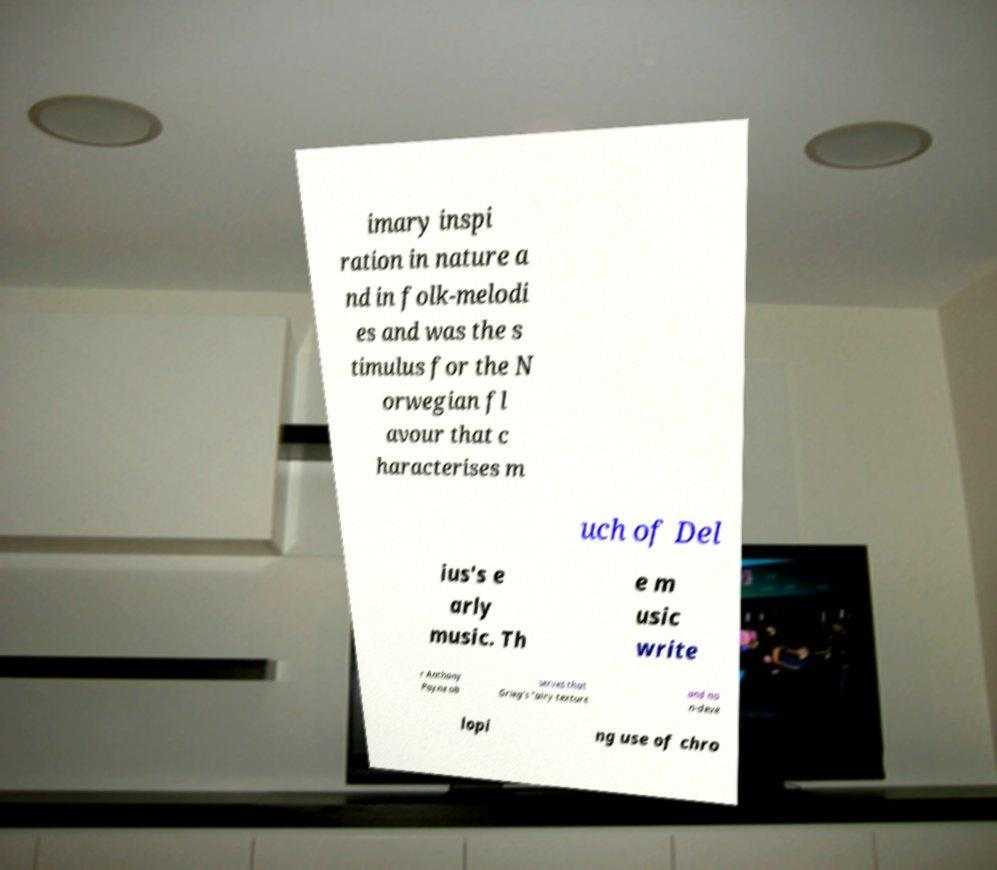I need the written content from this picture converted into text. Can you do that? imary inspi ration in nature a nd in folk-melodi es and was the s timulus for the N orwegian fl avour that c haracterises m uch of Del ius's e arly music. Th e m usic write r Anthony Payne ob serves that Grieg's "airy texture and no n-deve lopi ng use of chro 